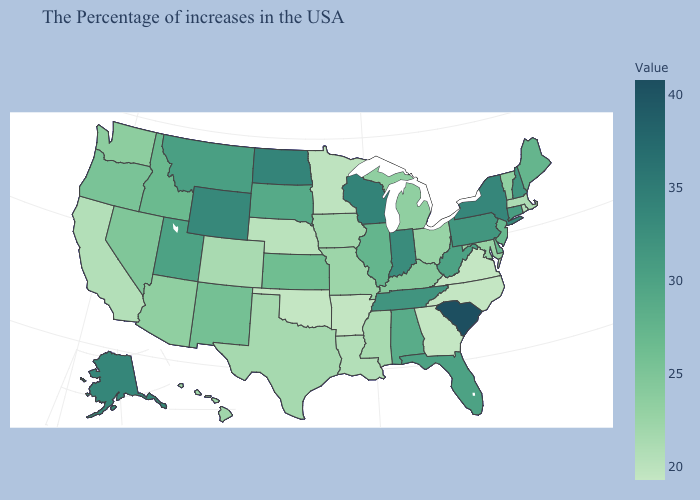Which states have the lowest value in the West?
Give a very brief answer. California. Which states have the lowest value in the USA?
Write a very short answer. Virginia, North Carolina, Georgia, Oklahoma. Does the map have missing data?
Keep it brief. No. Which states have the lowest value in the USA?
Concise answer only. Virginia, North Carolina, Georgia, Oklahoma. Among the states that border Idaho , does Washington have the lowest value?
Write a very short answer. Yes. Among the states that border California , does Nevada have the lowest value?
Quick response, please. No. Does Mississippi have a lower value than Indiana?
Give a very brief answer. Yes. 